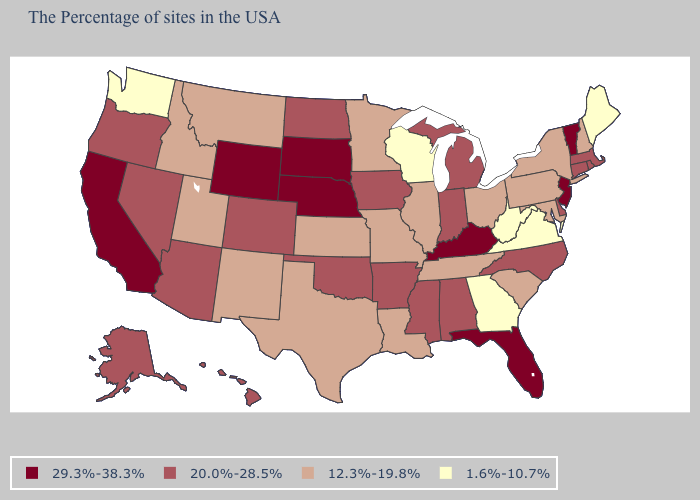What is the lowest value in the Northeast?
Concise answer only. 1.6%-10.7%. Among the states that border Connecticut , does New York have the lowest value?
Concise answer only. Yes. What is the value of Ohio?
Answer briefly. 12.3%-19.8%. What is the lowest value in the Northeast?
Concise answer only. 1.6%-10.7%. Does the map have missing data?
Quick response, please. No. Does Texas have the highest value in the USA?
Short answer required. No. Name the states that have a value in the range 1.6%-10.7%?
Quick response, please. Maine, Virginia, West Virginia, Georgia, Wisconsin, Washington. Does Kentucky have the highest value in the USA?
Concise answer only. Yes. Does Mississippi have a lower value than New Jersey?
Short answer required. Yes. Which states have the lowest value in the West?
Concise answer only. Washington. Which states hav the highest value in the Northeast?
Keep it brief. Vermont, New Jersey. Among the states that border Mississippi , which have the highest value?
Be succinct. Alabama, Arkansas. Name the states that have a value in the range 1.6%-10.7%?
Concise answer only. Maine, Virginia, West Virginia, Georgia, Wisconsin, Washington. What is the value of Maine?
Write a very short answer. 1.6%-10.7%. What is the lowest value in states that border Ohio?
Be succinct. 1.6%-10.7%. 